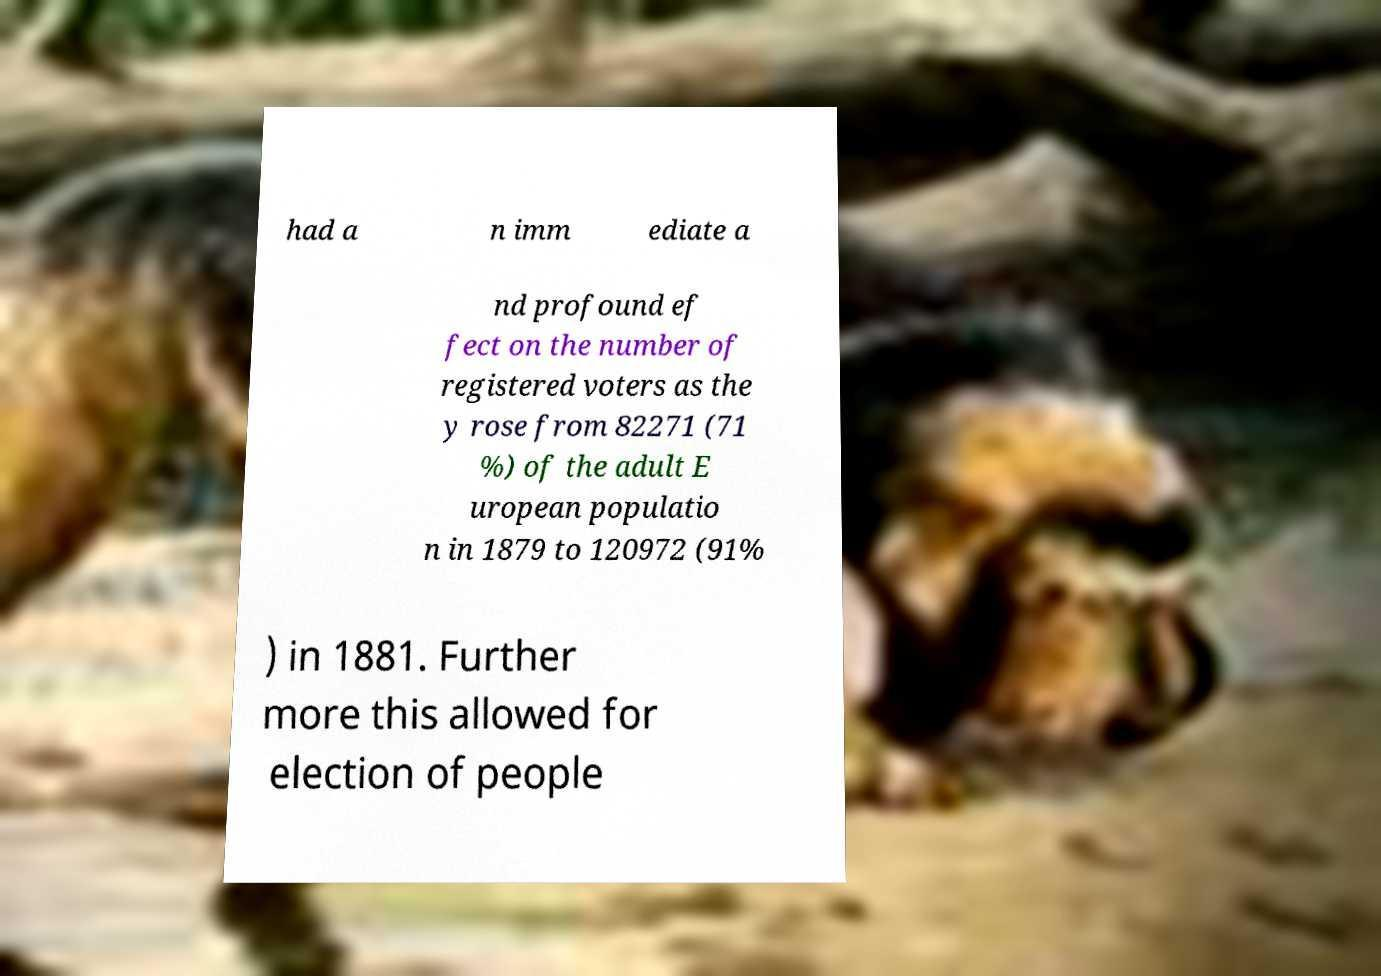I need the written content from this picture converted into text. Can you do that? had a n imm ediate a nd profound ef fect on the number of registered voters as the y rose from 82271 (71 %) of the adult E uropean populatio n in 1879 to 120972 (91% ) in 1881. Further more this allowed for election of people 